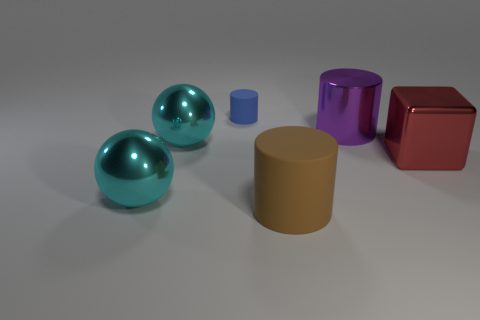Add 1 big shiny cubes. How many objects exist? 7 Subtract all spheres. How many objects are left? 4 Subtract all brown cylinders. Subtract all big cyan metallic things. How many objects are left? 3 Add 6 big cylinders. How many big cylinders are left? 8 Add 6 cyan things. How many cyan things exist? 8 Subtract 0 purple blocks. How many objects are left? 6 